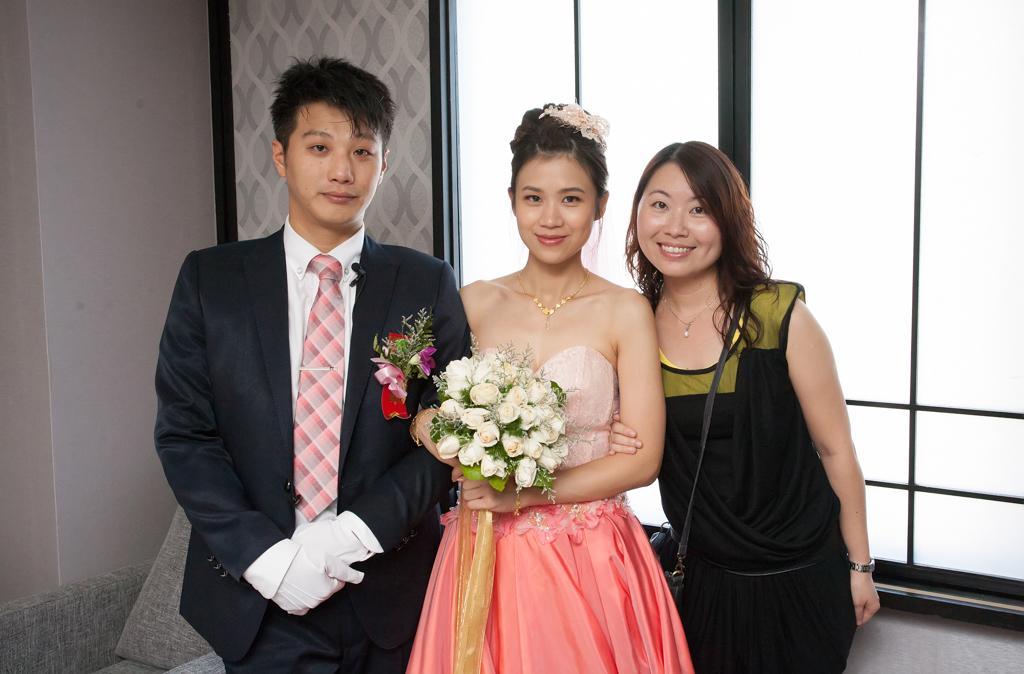How would you summarize this image in a sentence or two? In this image I can see two women and a man. In the background I can see a window. One of the woman is holding a bouquet 